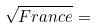<formula> <loc_0><loc_0><loc_500><loc_500>\sqrt { F r a n c e } =</formula> 